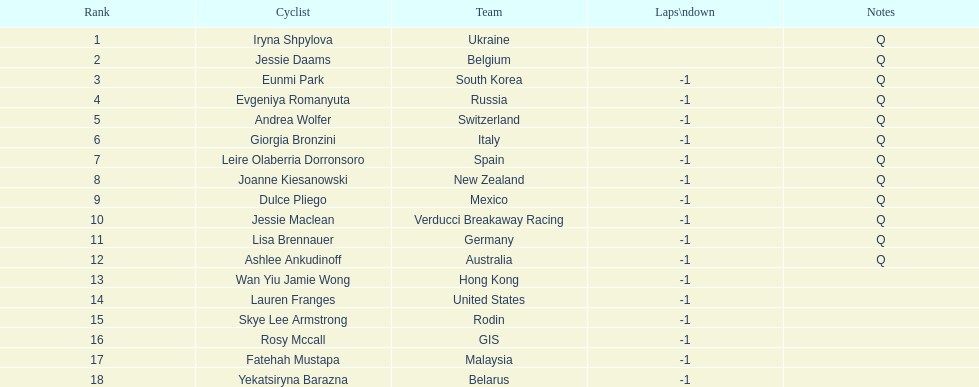What two bike riders are part of teams with no laps down? Iryna Shpylova, Jessie Daams. 